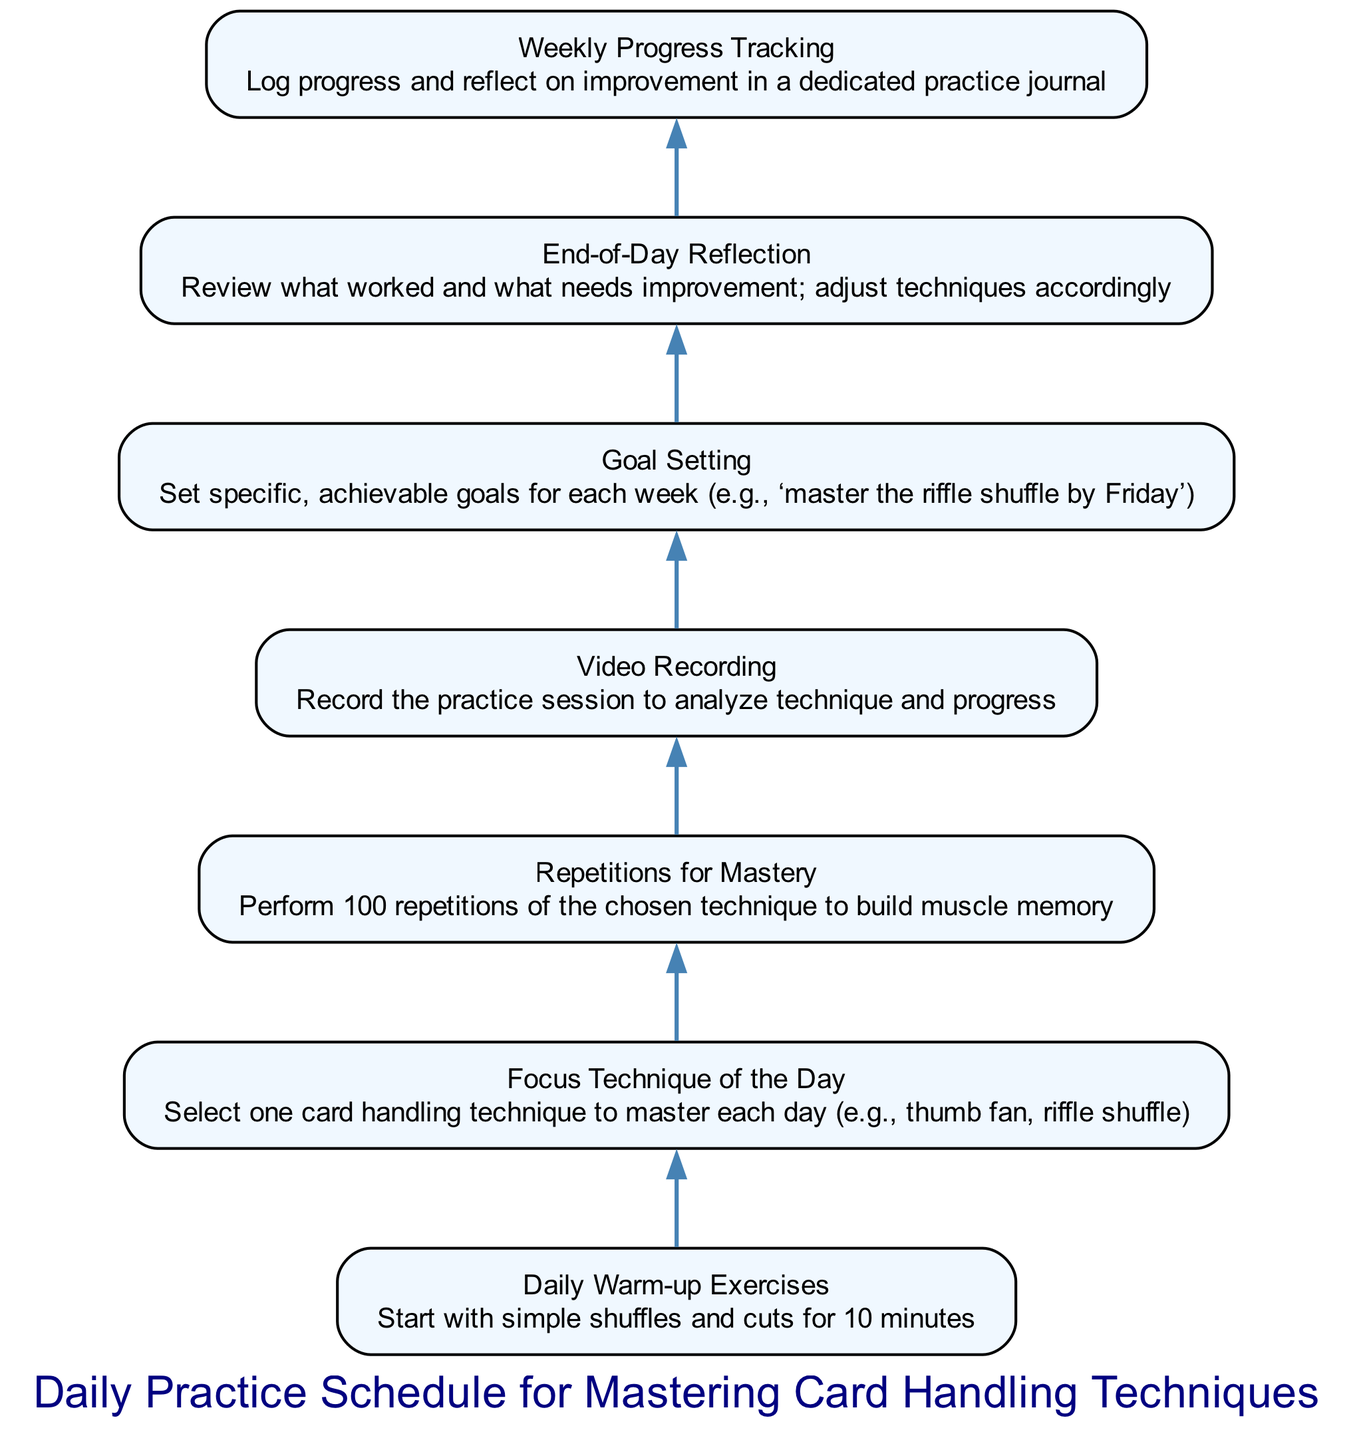What is the first step in the process? The diagram indicates that the first step is "Daily Warm-up Exercises," which involves starting with simple shuffles and cuts for 10 minutes.
Answer: Daily Warm-up Exercises How many total elements are in the diagram? Counting the nodes in the diagram, there are a total of seven elements listed in the practice schedule.
Answer: Seven What is the goal of the "Focus Technique of the Day"? The goal specified in this node is to select one card handling technique to master each day, such as the thumb fan or riffle shuffle.
Answer: Select one card handling technique What activity follows "Repetitions for Mastery"? According to the flow in the diagram, "Video Recording" directly follows "Repetitions for Mastery."
Answer: Video Recording What is required for "Weekly Progress Tracking"? The "Weekly Progress Tracking" section requires logging progress and reflecting on improvement in a dedicated practice journal.
Answer: Log progress and reflect Which node emphasizes adjusting techniques? The "End-of-Day Reflection" node emphasizes reviewing what worked and what needs improvement, leading to adjustments in techniques.
Answer: End-of-Day Reflection What type of goals should be set in the "Goal Setting" step? The goals set in this step should be specific and achievable for each week, such as mastering the riffle shuffle by Friday.
Answer: Specific, achievable goals How does "Video Recording" help in the practice schedule? "Video Recording" helps analyze the technique and track progress through recorded practice sessions.
Answer: Analyze technique and progress Which node connects all the other nodes in a sequential order? The entire sequence of nodes is connected in a bottom-up manner, with the initial node, "Daily Warm-up Exercises," being the starting point that leads to other nodes in a linear fashion.
Answer: Daily Warm-up Exercises 